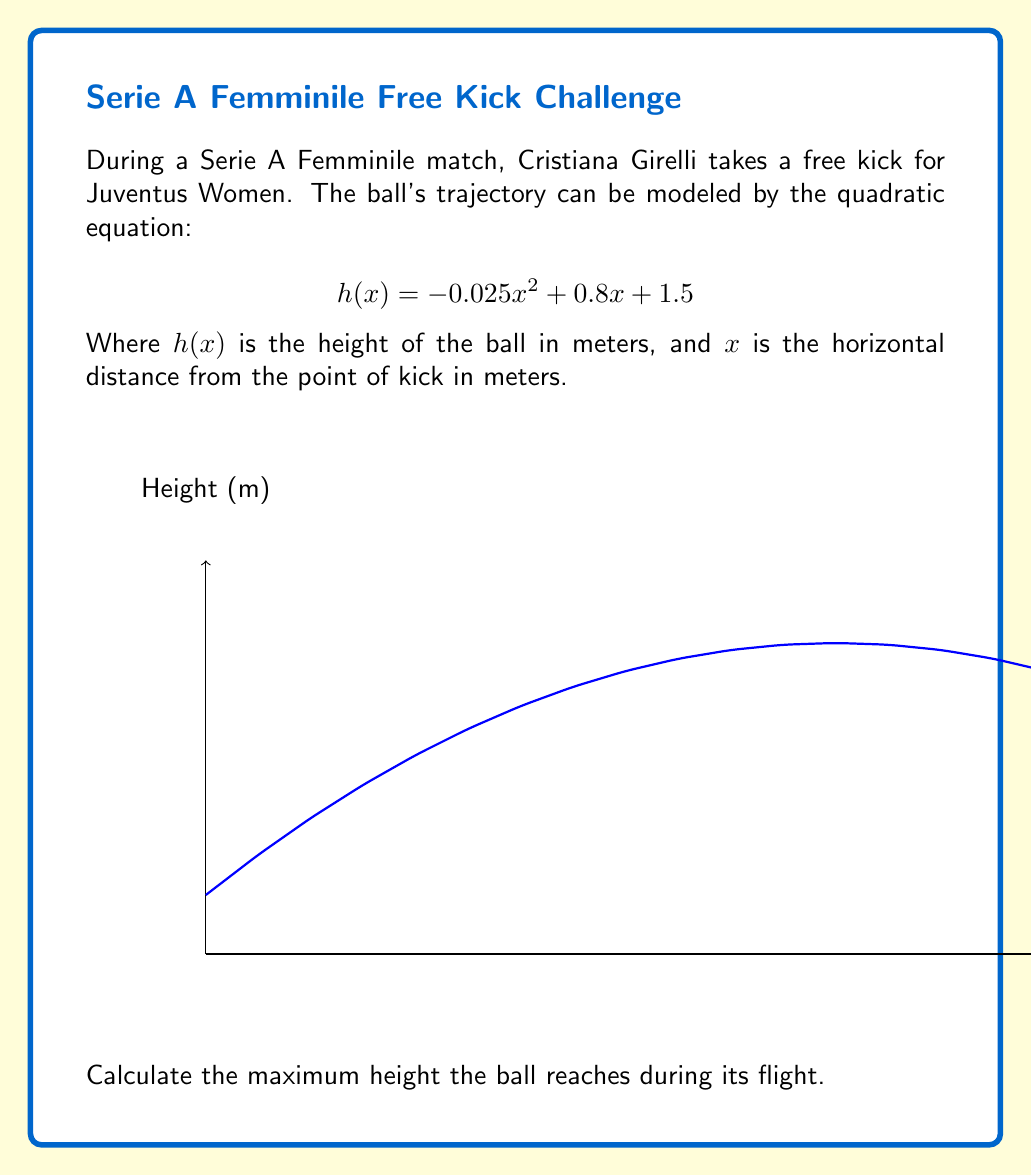Could you help me with this problem? To find the maximum height of the ball's trajectory, we need to follow these steps:

1) The quadratic equation given is in the form $h(x) = ax^2 + bx + c$, where:
   $a = -0.025$
   $b = 0.8$
   $c = 1.5$

2) For a quadratic function, the x-coordinate of the vertex represents the point where the function reaches its maximum (if $a < 0$) or minimum (if $a > 0$).

3) The formula for the x-coordinate of the vertex is: $x = -\frac{b}{2a}$

4) Substituting our values:
   $$x = -\frac{0.8}{2(-0.025)} = -\frac{0.8}{-0.05} = 16$$

5) To find the maximum height, we need to calculate $h(16)$:

   $$h(16) = -0.025(16)^2 + 0.8(16) + 1.5$$
   $$= -0.025(256) + 12.8 + 1.5$$
   $$= -6.4 + 12.8 + 1.5$$
   $$= 7.9$$

Therefore, the maximum height the ball reaches is 7.9 meters.
Answer: 7.9 meters 